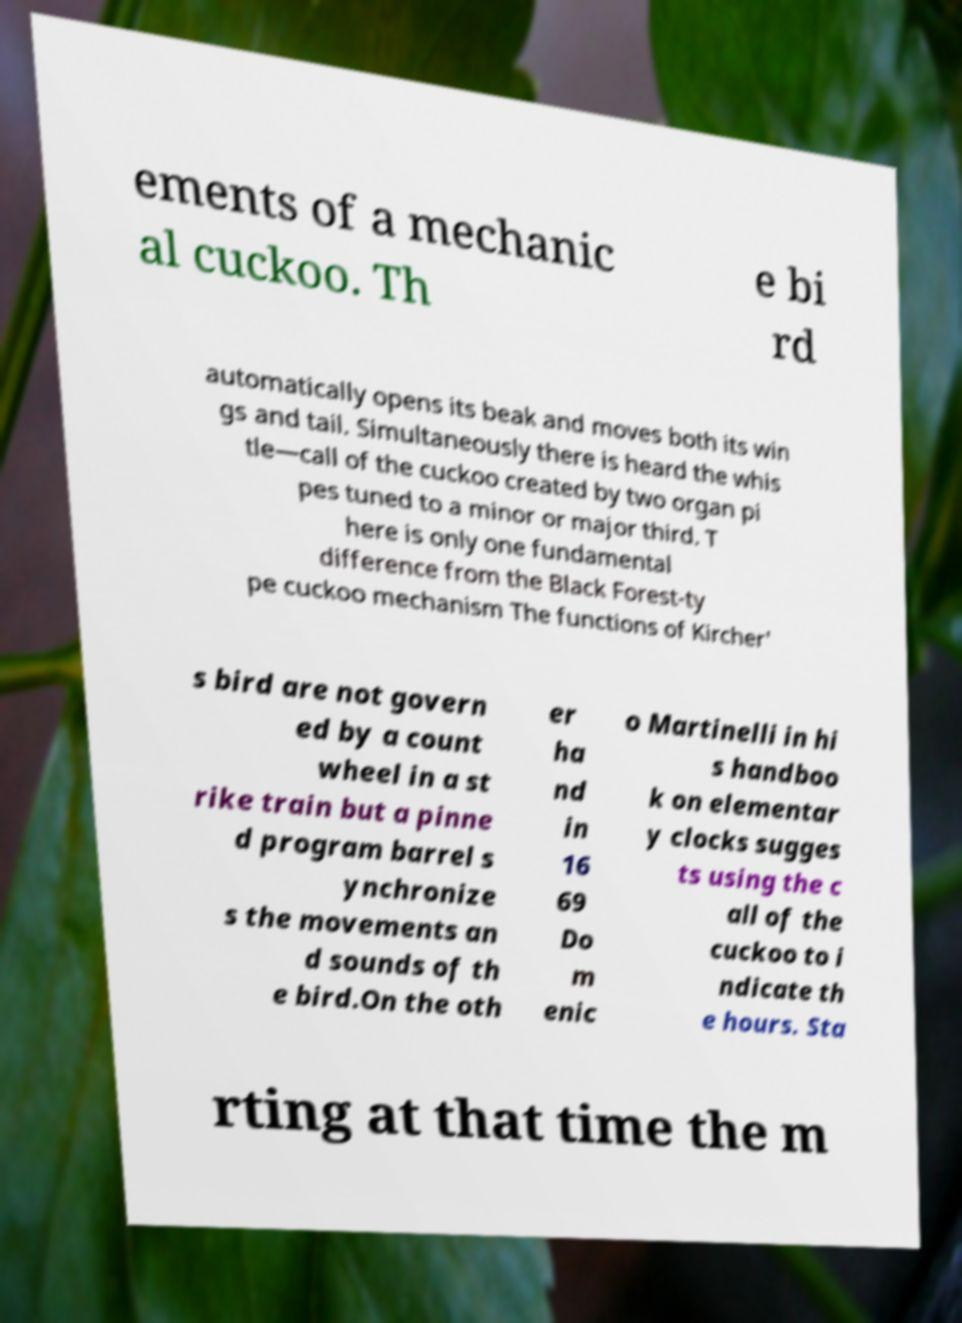What messages or text are displayed in this image? I need them in a readable, typed format. ements of a mechanic al cuckoo. Th e bi rd automatically opens its beak and moves both its win gs and tail. Simultaneously there is heard the whis tle—call of the cuckoo created by two organ pi pes tuned to a minor or major third. T here is only one fundamental difference from the Black Forest-ty pe cuckoo mechanism The functions of Kircher' s bird are not govern ed by a count wheel in a st rike train but a pinne d program barrel s ynchronize s the movements an d sounds of th e bird.On the oth er ha nd in 16 69 Do m enic o Martinelli in hi s handboo k on elementar y clocks sugges ts using the c all of the cuckoo to i ndicate th e hours. Sta rting at that time the m 